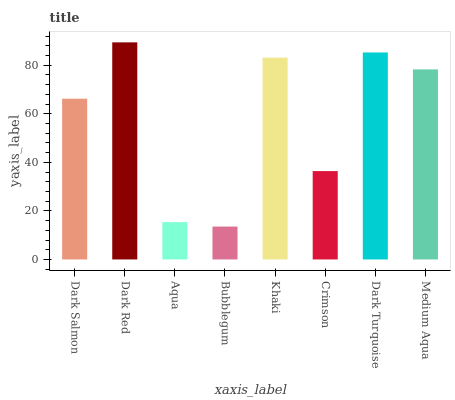Is Bubblegum the minimum?
Answer yes or no. Yes. Is Dark Red the maximum?
Answer yes or no. Yes. Is Aqua the minimum?
Answer yes or no. No. Is Aqua the maximum?
Answer yes or no. No. Is Dark Red greater than Aqua?
Answer yes or no. Yes. Is Aqua less than Dark Red?
Answer yes or no. Yes. Is Aqua greater than Dark Red?
Answer yes or no. No. Is Dark Red less than Aqua?
Answer yes or no. No. Is Medium Aqua the high median?
Answer yes or no. Yes. Is Dark Salmon the low median?
Answer yes or no. Yes. Is Dark Salmon the high median?
Answer yes or no. No. Is Bubblegum the low median?
Answer yes or no. No. 